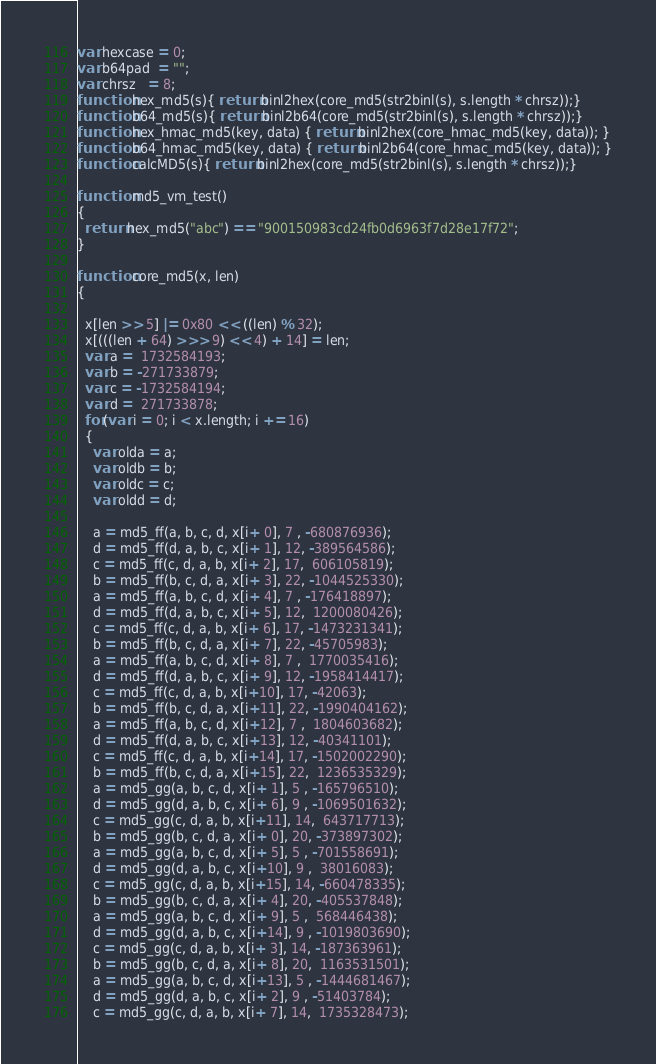<code> <loc_0><loc_0><loc_500><loc_500><_JavaScript_>var hexcase = 0;  
var b64pad  = ""; 
var chrsz   = 8;  
function hex_md5(s){ return binl2hex(core_md5(str2binl(s), s.length * chrsz));}
function b64_md5(s){ return binl2b64(core_md5(str2binl(s), s.length * chrsz));}
function hex_hmac_md5(key, data) { return binl2hex(core_hmac_md5(key, data)); }
function b64_hmac_md5(key, data) { return binl2b64(core_hmac_md5(key, data)); }
function calcMD5(s){ return binl2hex(core_md5(str2binl(s), s.length * chrsz));}

function md5_vm_test()
{
  return hex_md5("abc") == "900150983cd24fb0d6963f7d28e17f72";
}

function core_md5(x, len)
{

  x[len >> 5] |= 0x80 << ((len) % 32);
  x[(((len + 64) >>> 9) << 4) + 14] = len;
  var a =  1732584193;
  var b = -271733879;
  var c = -1732584194;
  var d =  271733878;
  for(var i = 0; i < x.length; i += 16)
  {
    var olda = a;
    var oldb = b;
    var oldc = c;
    var oldd = d;

    a = md5_ff(a, b, c, d, x[i+ 0], 7 , -680876936);
    d = md5_ff(d, a, b, c, x[i+ 1], 12, -389564586);
    c = md5_ff(c, d, a, b, x[i+ 2], 17,  606105819);
    b = md5_ff(b, c, d, a, x[i+ 3], 22, -1044525330);
    a = md5_ff(a, b, c, d, x[i+ 4], 7 , -176418897);
    d = md5_ff(d, a, b, c, x[i+ 5], 12,  1200080426);
    c = md5_ff(c, d, a, b, x[i+ 6], 17, -1473231341);
    b = md5_ff(b, c, d, a, x[i+ 7], 22, -45705983);
    a = md5_ff(a, b, c, d, x[i+ 8], 7 ,  1770035416);
    d = md5_ff(d, a, b, c, x[i+ 9], 12, -1958414417);
    c = md5_ff(c, d, a, b, x[i+10], 17, -42063);
    b = md5_ff(b, c, d, a, x[i+11], 22, -1990404162);
    a = md5_ff(a, b, c, d, x[i+12], 7 ,  1804603682);
    d = md5_ff(d, a, b, c, x[i+13], 12, -40341101);
    c = md5_ff(c, d, a, b, x[i+14], 17, -1502002290);
    b = md5_ff(b, c, d, a, x[i+15], 22,  1236535329);
    a = md5_gg(a, b, c, d, x[i+ 1], 5 , -165796510);
    d = md5_gg(d, a, b, c, x[i+ 6], 9 , -1069501632);
    c = md5_gg(c, d, a, b, x[i+11], 14,  643717713);
    b = md5_gg(b, c, d, a, x[i+ 0], 20, -373897302);
    a = md5_gg(a, b, c, d, x[i+ 5], 5 , -701558691);
    d = md5_gg(d, a, b, c, x[i+10], 9 ,  38016083);
    c = md5_gg(c, d, a, b, x[i+15], 14, -660478335);
    b = md5_gg(b, c, d, a, x[i+ 4], 20, -405537848);
    a = md5_gg(a, b, c, d, x[i+ 9], 5 ,  568446438);
    d = md5_gg(d, a, b, c, x[i+14], 9 , -1019803690);
    c = md5_gg(c, d, a, b, x[i+ 3], 14, -187363961);
    b = md5_gg(b, c, d, a, x[i+ 8], 20,  1163531501);
    a = md5_gg(a, b, c, d, x[i+13], 5 , -1444681467);
    d = md5_gg(d, a, b, c, x[i+ 2], 9 , -51403784);
    c = md5_gg(c, d, a, b, x[i+ 7], 14,  1735328473);</code> 